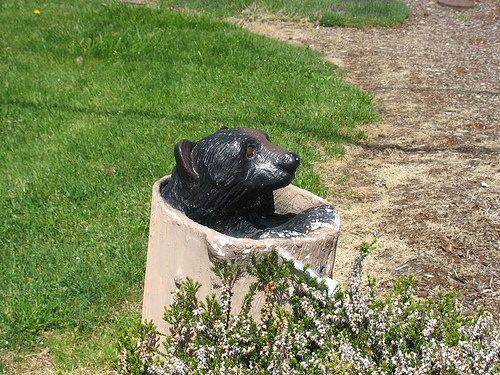Describe the objects in this image and their specific colors. I can see various objects in this image with different colors. 